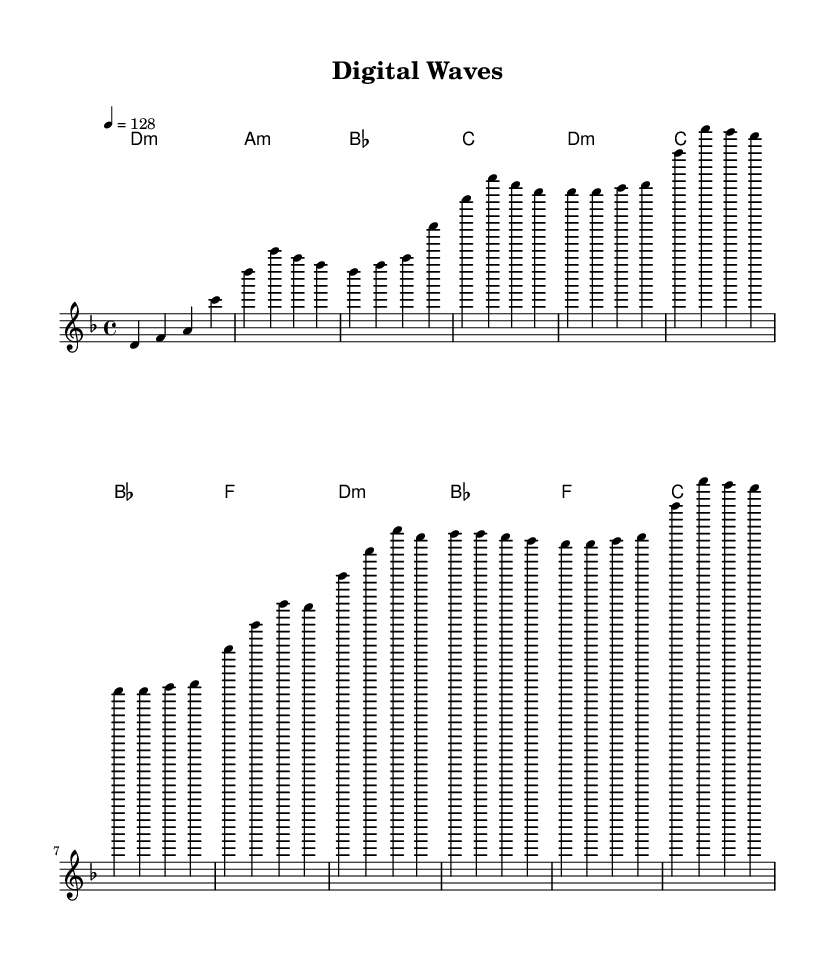What is the key signature of this music? The key signature is D minor, which typically features one flat (B flat) and is indicated at the beginning of the staff.
Answer: D minor What is the time signature of this music? The time signature is found in the first measure and is denoted as 4/4, meaning there are four beats in each measure and a quarter note receives one beat.
Answer: 4/4 What is the tempo of this music? The tempo marking indicates that the music should be played at a speed of 128 beats per minute, as shown at the beginning of the score.
Answer: 128 How many measures are in the verse section? The verse section consists of 8 measures, which can be counted visually from the corresponding notation in the melody and harmonies.
Answer: 8 What type of chords are predominantly used in the chorus? The chorus primarily features minor chords, which can be identified by observing the harmonic context within the chorus measures.
Answer: minor chords In what form is the music structured? The music follows the verse-chorus structure, which is common in K-pop, evident by the distinct sections marked by changes in melody and harmony.
Answer: verse-chorus Which element in the music reflects the electronic influence? The introduction of synthesized sounds or effects often associated with electronic music would be evident in a performance or arrangement, although not explicitly shown in the sheet music itself.
Answer: synthesized sounds 